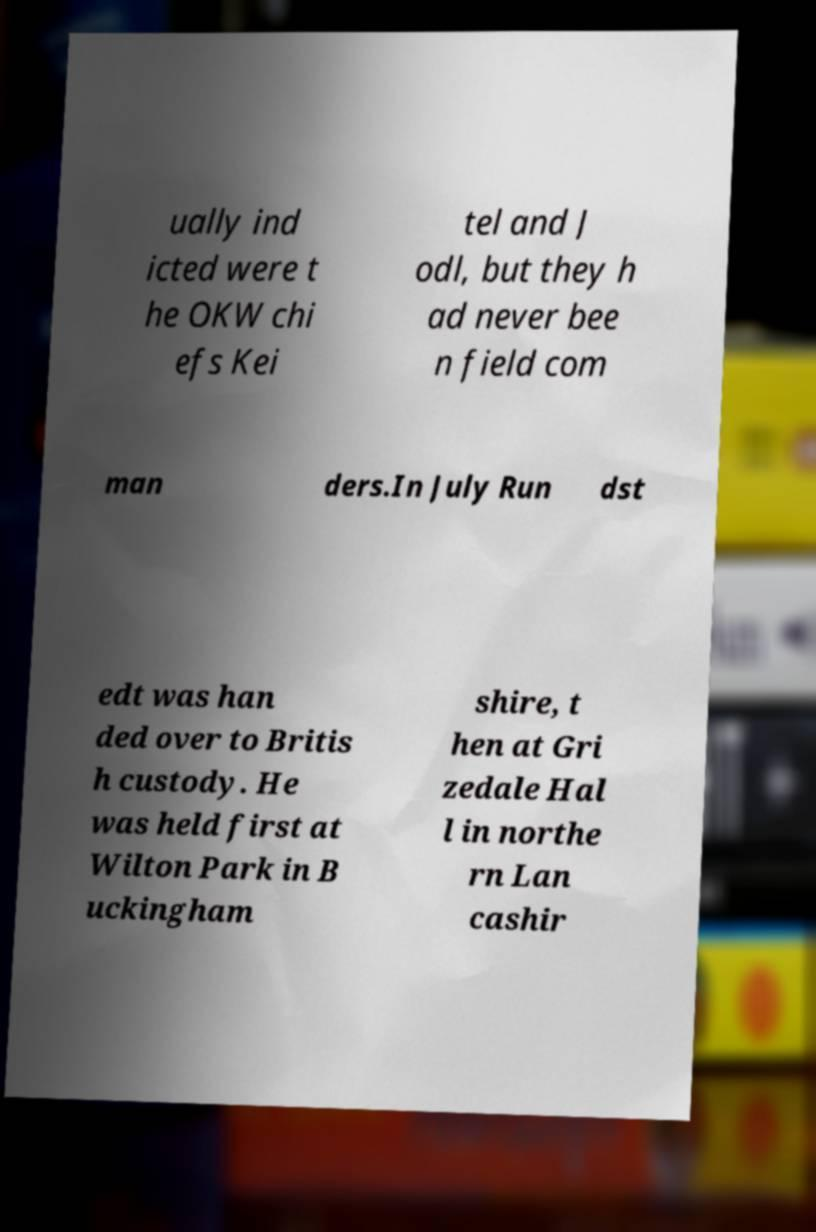I need the written content from this picture converted into text. Can you do that? ually ind icted were t he OKW chi efs Kei tel and J odl, but they h ad never bee n field com man ders.In July Run dst edt was han ded over to Britis h custody. He was held first at Wilton Park in B uckingham shire, t hen at Gri zedale Hal l in northe rn Lan cashir 